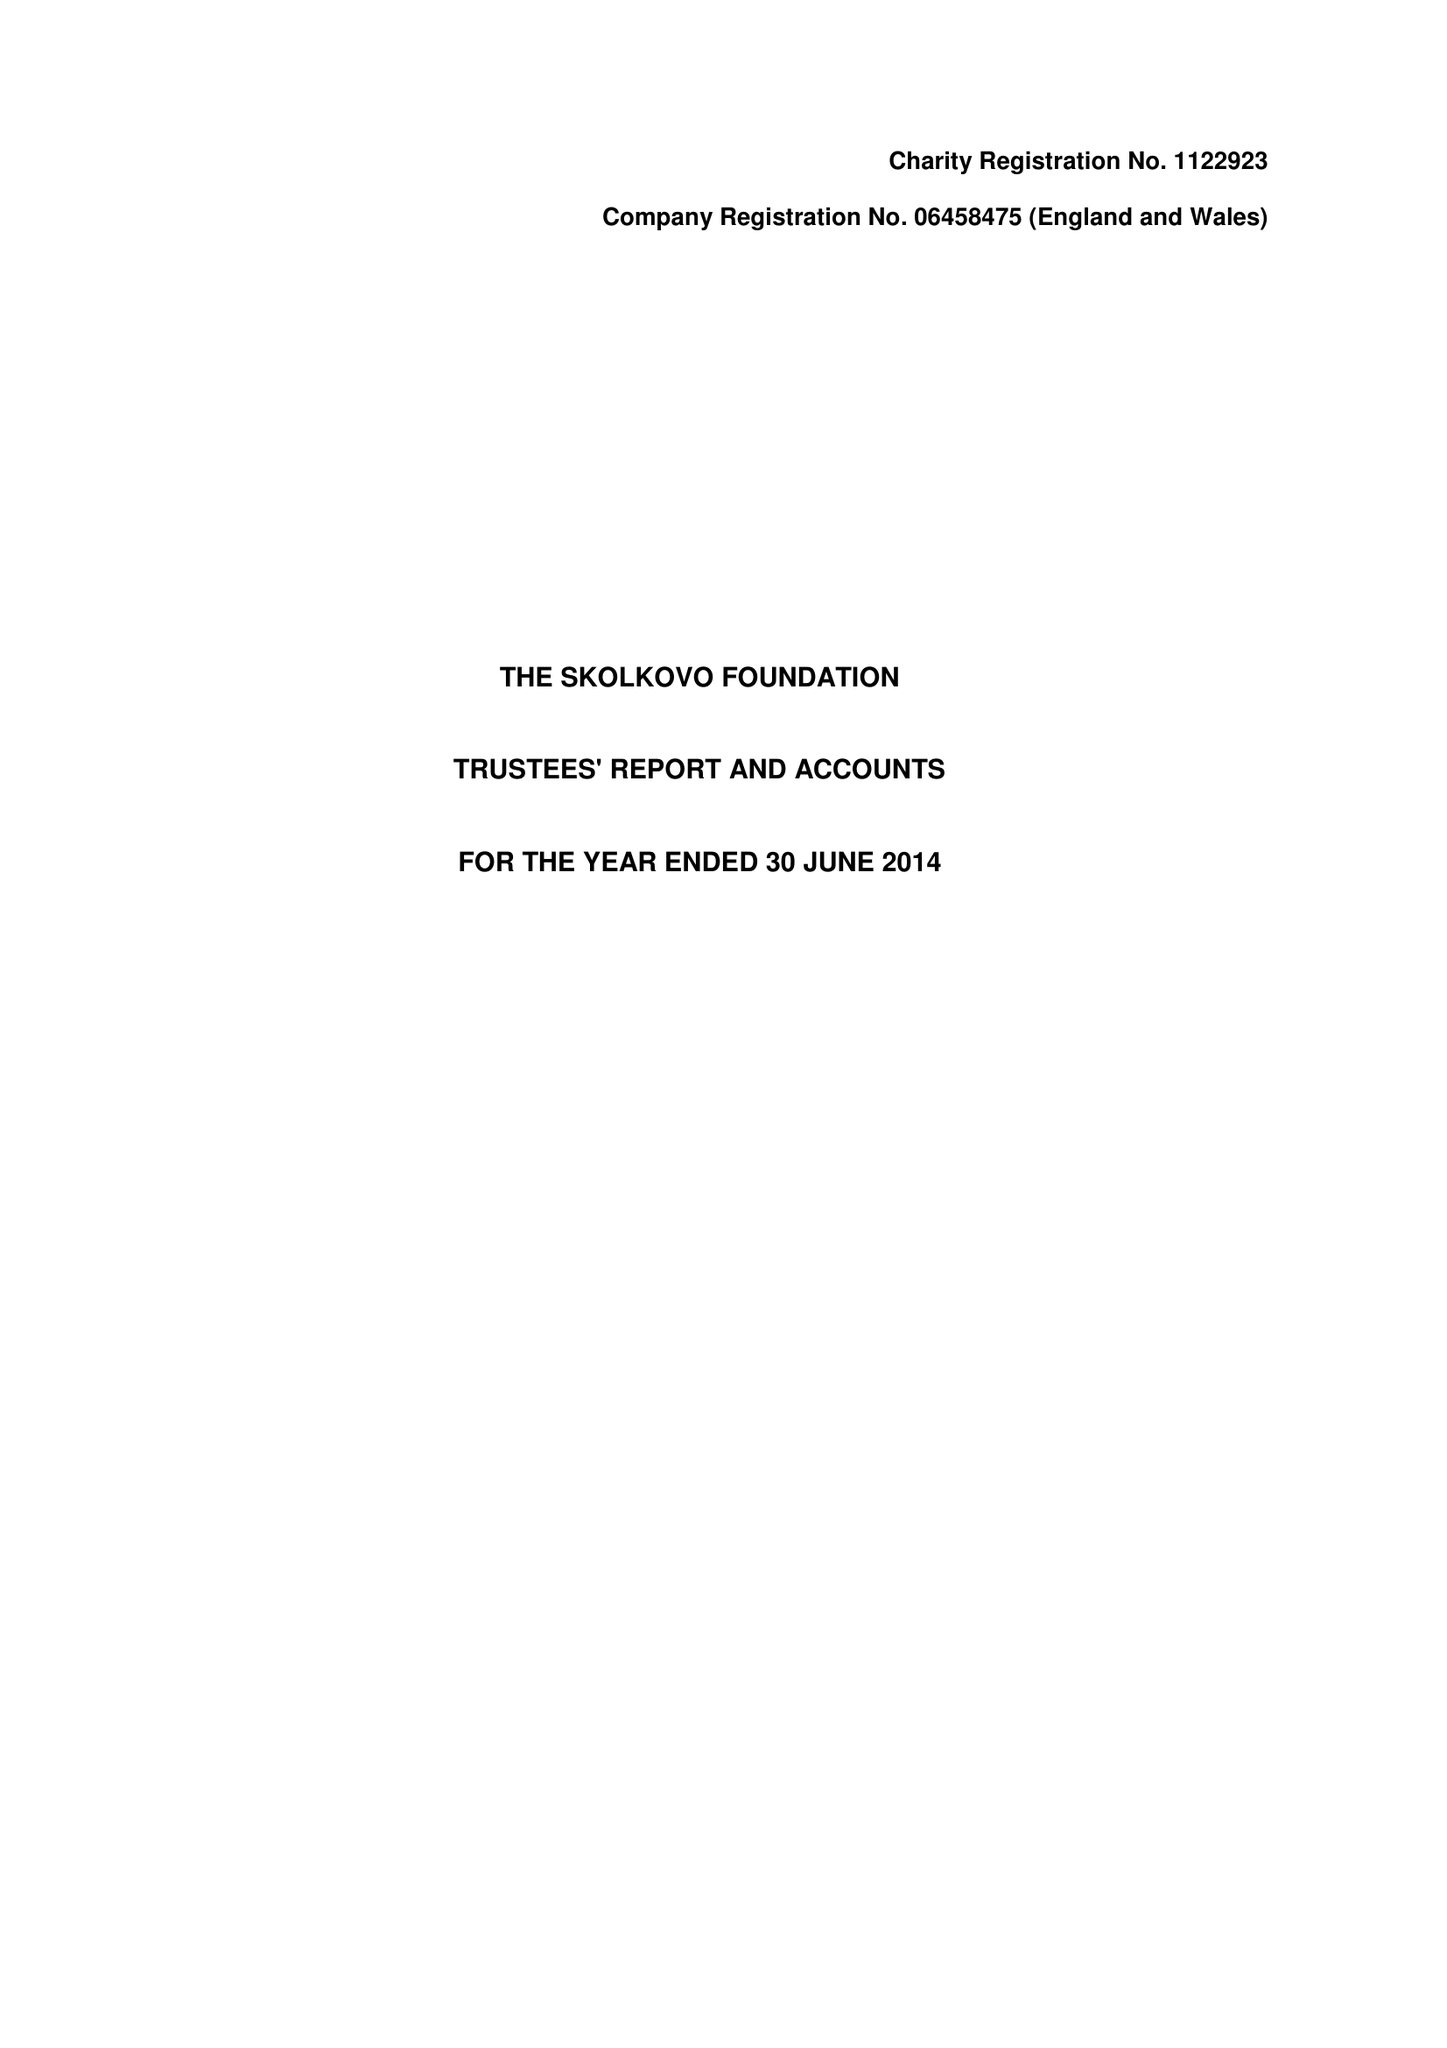What is the value for the report_date?
Answer the question using a single word or phrase. 2014-06-30 